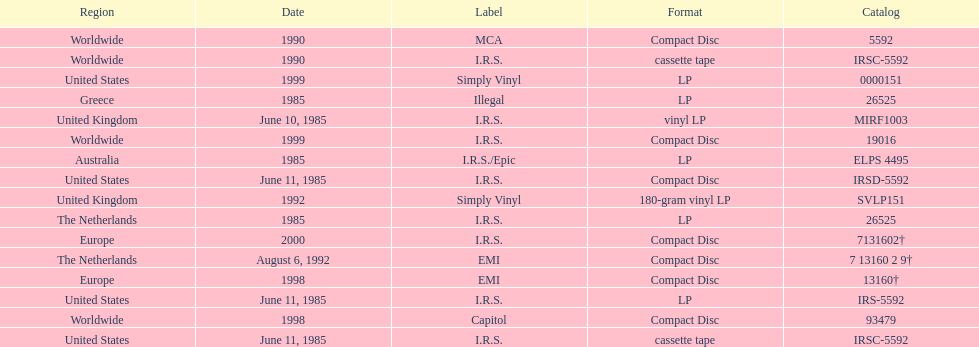Name another region for the 1985 release other than greece. Australia. 